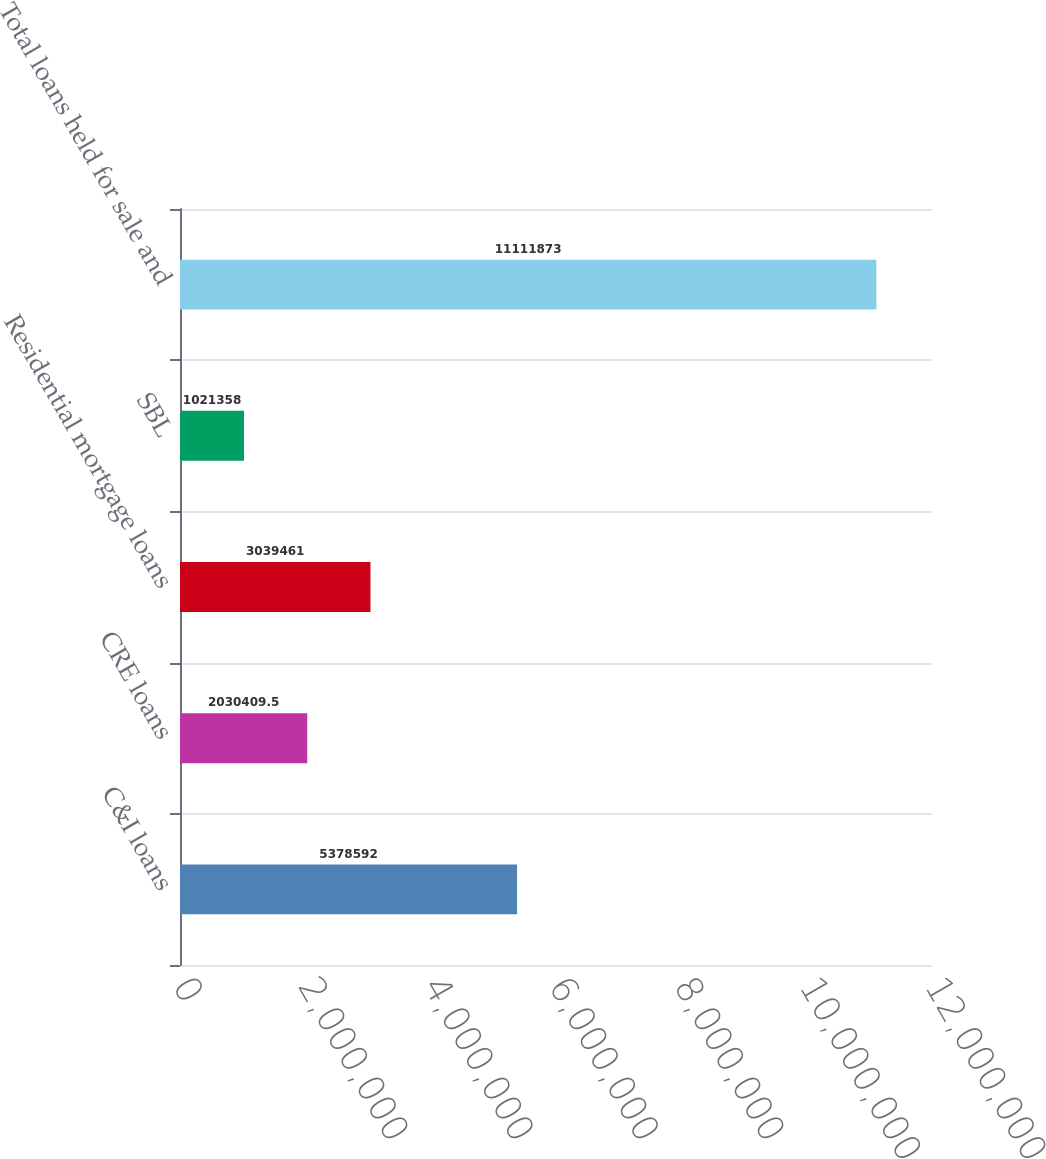<chart> <loc_0><loc_0><loc_500><loc_500><bar_chart><fcel>C&I loans<fcel>CRE loans<fcel>Residential mortgage loans<fcel>SBL<fcel>Total loans held for sale and<nl><fcel>5.37859e+06<fcel>2.03041e+06<fcel>3.03946e+06<fcel>1.02136e+06<fcel>1.11119e+07<nl></chart> 